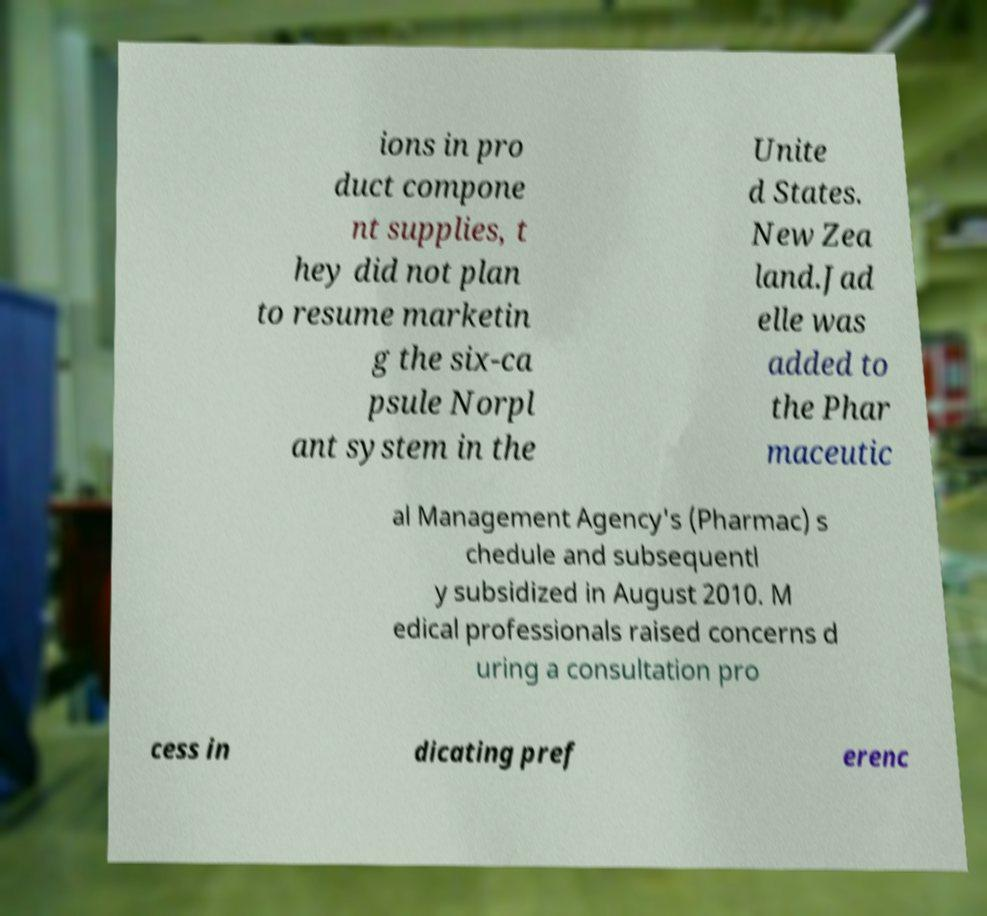Can you read and provide the text displayed in the image?This photo seems to have some interesting text. Can you extract and type it out for me? ions in pro duct compone nt supplies, t hey did not plan to resume marketin g the six-ca psule Norpl ant system in the Unite d States. New Zea land.Jad elle was added to the Phar maceutic al Management Agency's (Pharmac) s chedule and subsequentl y subsidized in August 2010. M edical professionals raised concerns d uring a consultation pro cess in dicating pref erenc 